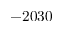Convert formula to latex. <formula><loc_0><loc_0><loc_500><loc_500>- 2 0 3 0</formula> 